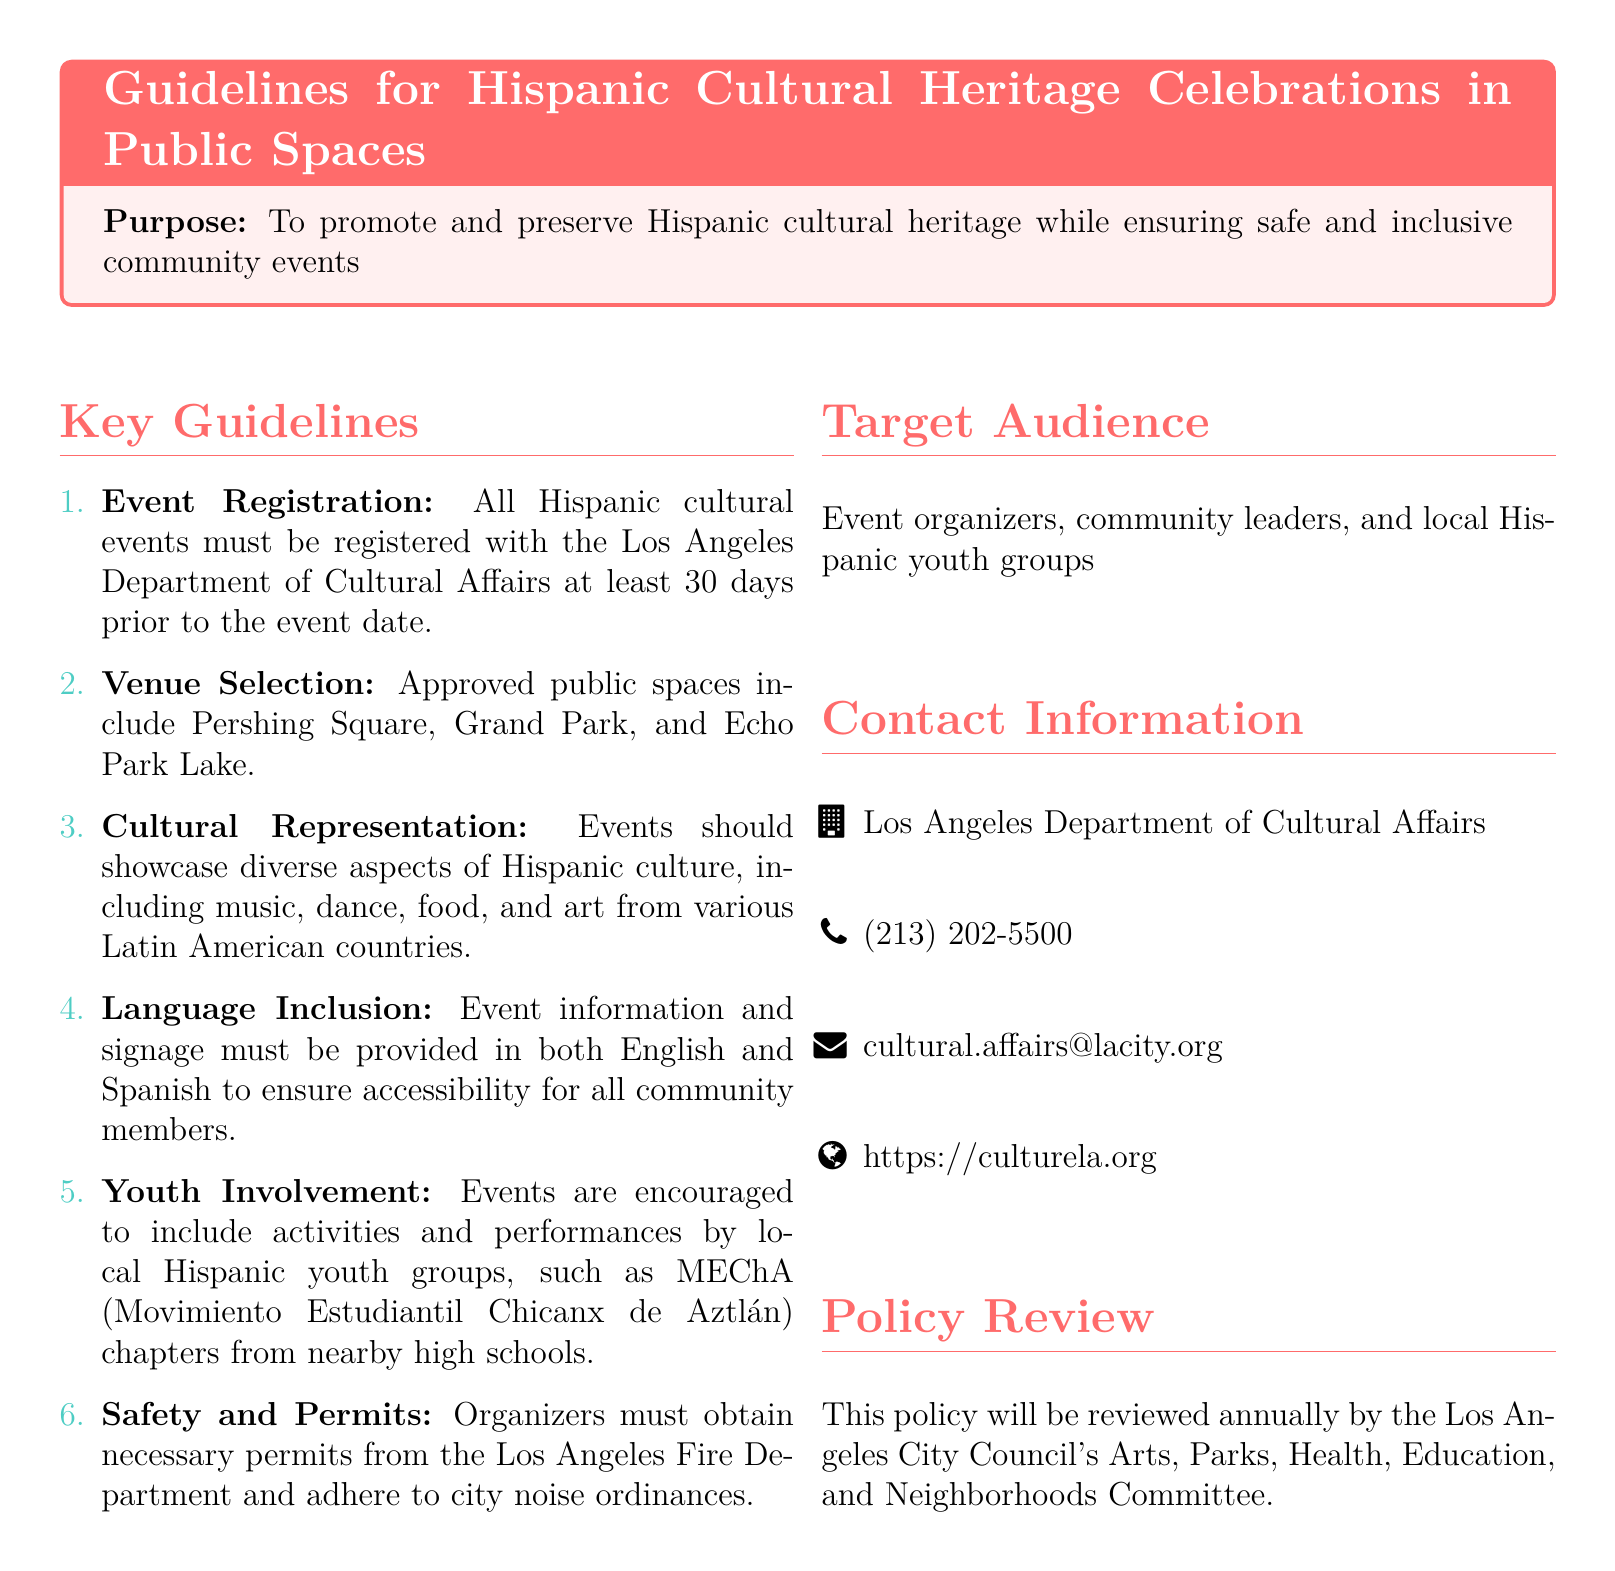What is the purpose of the guidelines? The purpose is to promote and preserve Hispanic cultural heritage while ensuring safe and inclusive community events.
Answer: To promote and preserve Hispanic cultural heritage while ensuring safe and inclusive community events How many days prior to the event must it be registered? The document states that events must be registered at least 30 days prior to the event date.
Answer: 30 days What types of public spaces are approved for events? The approved public spaces mentioned include Pershing Square, Grand Park, and Echo Park Lake.
Answer: Pershing Square, Grand Park, Echo Park Lake What languages must event information be provided in? The guidelines indicate that event information and signage must be provided in both English and Spanish for accessibility.
Answer: English and Spanish What is one encouraged group for youth involvement? The policy encourages participation from local Hispanic youth groups, specifically mentioning MEChA chapters from nearby high schools.
Answer: MEChA What must organizers obtain from the Los Angeles Fire Department? Organizers are required to obtain necessary permits from the Los Angeles Fire Department as per the safety guidelines.
Answer: Permits When will the policy be reviewed? The policy is set to be reviewed annually by the Los Angeles City Council's Arts, Parks, Health, Education, and Neighborhoods Committee.
Answer: Annually Who can be contacted for more information? The document provides contact information for the Los Angeles Department of Cultural Affairs as a point of contact for inquiries.
Answer: Los Angeles Department of Cultural Affairs 